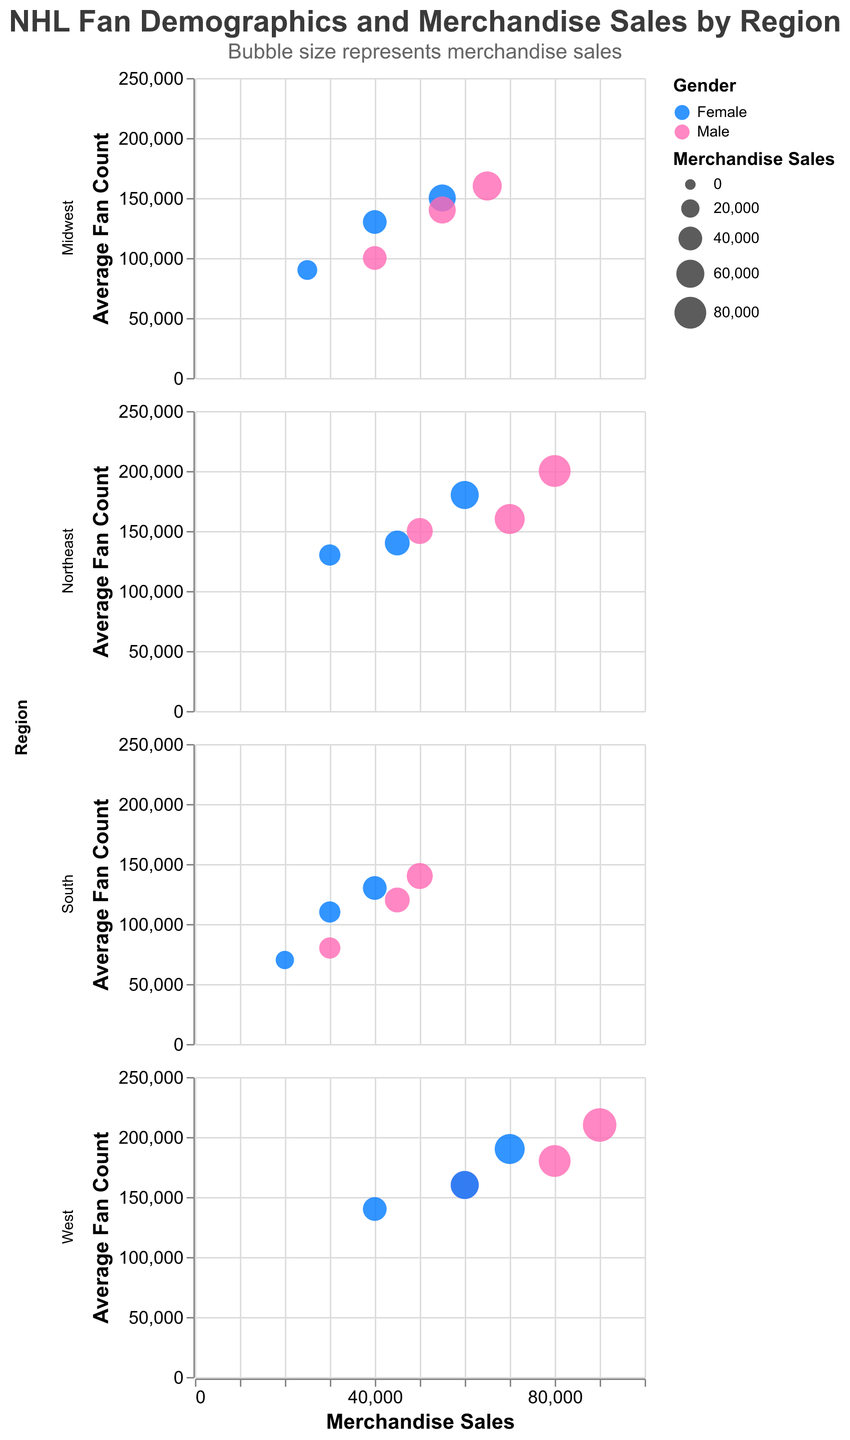Which region has the highest merchandise sales for the male group aged 25-34? The highest mark for males aged 25-34 is visualized by the largest bubble in the West region's subplot. It indicates $90,000 in merchandise sales.
Answer: West How does the fan count for Midwest females aged 18-24 compare to that of South females aged 35-44? In the subplot for the Midwest, the circle for females aged 18-24 has a fan count of 90,000. In the South subplot, the circle for females aged 35-44 shows a fan count of 110,000. 110,000 is greater than 90,000.
Answer: South females aged 35-44 What is the average merchandise sales for the 35-44 age group across all regions? Summing the merchandise sales for the 35-44 age group in all regions (70,000+45,000)+(55,000+40,000)+(45,000+30,000)+(80,000+60,000) equals 425,000. Dividing by the 8 data points, the average is 425,000/8 = 53,125.
Answer: 53,125 Which age group in the Northeast has the highest average fan count for males? In the Northeast subplot, males aged 25-34 have the highest average fan count at 200,000, compared to males aged 18-24 with 150,000 and 35-44 with 160,000.
Answer: 25-34 What is the correlation between merchandise sales and average fan count for females in the South? The subgroups in the South region show a trend: as merchandise sales increase (from 20,000 to 40,000 to 30,000), the average fan count similarly increases (from 70,000 to 130,000 to 110,000), indicating a positive correlation.
Answer: Positive correlation Does the West region show any significant disparity in merchandise sales between male and female fans aged 18-24? In the West subplot, merchandise sales for males aged 18-24 are shown by a larger bubble ($60,000) compared to the smaller bubble for females aged 18-24 ($40,000). The disparity is 20,000.
Answer: Yes, $20,000 Identify the region with the least merchandise sales for females across all age groups. Examination of each subplot reveals that the smallest merchandise sales for females across all age groups are in the South, where the sales range from $20,000 to $40,000.
Answer: South Is there any age group in the West which demonstrates a balanced fan count regardless of gender? In the West subplot, the age group 18-24 shows fairly balanced fan counts, with males at 160,000 and females slightly below at 140,000. Other groups display wider disparities.
Answer: 18-24 Which gender in the Northeast, aged 35-44, has achieved higher merchandise sales? By examining the circles in the Northeast subplot for the 35-44 age group, males have a merchandise sales figure of $70,000 compared to females at $45,000. Hence, males have higher sales.
Answer: Male 